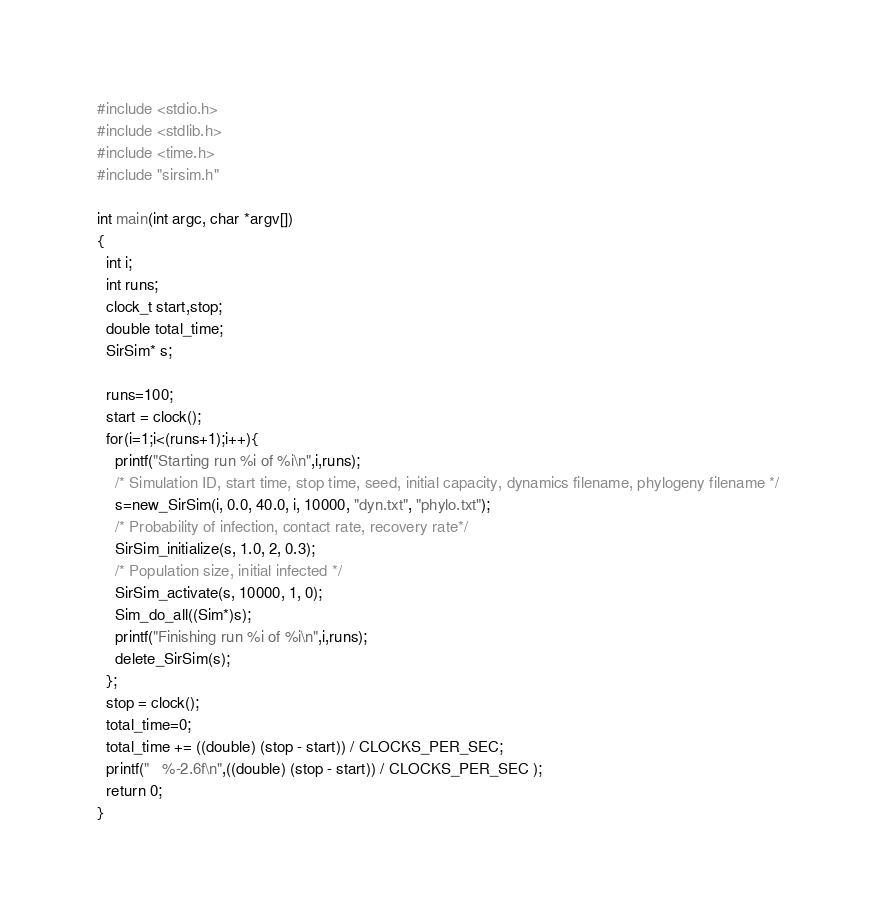Convert code to text. <code><loc_0><loc_0><loc_500><loc_500><_C_>#include <stdio.h>
#include <stdlib.h>
#include <time.h>
#include "sirsim.h"

int main(int argc, char *argv[])
{
  int i;
  int runs;
  clock_t start,stop;
  double total_time;
  SirSim* s;
  
  runs=100;
  start = clock();
  for(i=1;i<(runs+1);i++){
    printf("Starting run %i of %i\n",i,runs);
    /* Simulation ID, start time, stop time, seed, initial capacity, dynamics filename, phylogeny filename */
    s=new_SirSim(i, 0.0, 40.0, i, 10000, "dyn.txt", "phylo.txt");
    /* Probability of infection, contact rate, recovery rate*/
    SirSim_initialize(s, 1.0, 2, 0.3);
    /* Population size, initial infected */
    SirSim_activate(s, 10000, 1, 0);                 
    Sim_do_all((Sim*)s);
    printf("Finishing run %i of %i\n",i,runs);
    delete_SirSim(s);
  };
  stop = clock();
  total_time=0;
  total_time += ((double) (stop - start)) / CLOCKS_PER_SEC;
  printf("   %-2.6f\n",((double) (stop - start)) / CLOCKS_PER_SEC );
  return 0;
}
</code> 